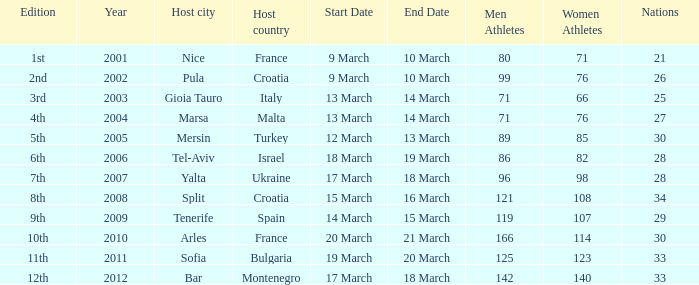What was the number of athletes in the host city of Nice? 80 men/71 women. 